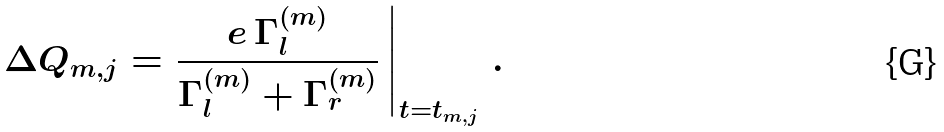Convert formula to latex. <formula><loc_0><loc_0><loc_500><loc_500>\Delta Q _ { m , j } = \left . \frac { e \, \Gamma _ { l } ^ { ( m ) } } { \Gamma _ { l } ^ { ( m ) } + \Gamma _ { r } ^ { ( m ) } } \, \right | _ { t = t _ { m , j } } \, .</formula> 